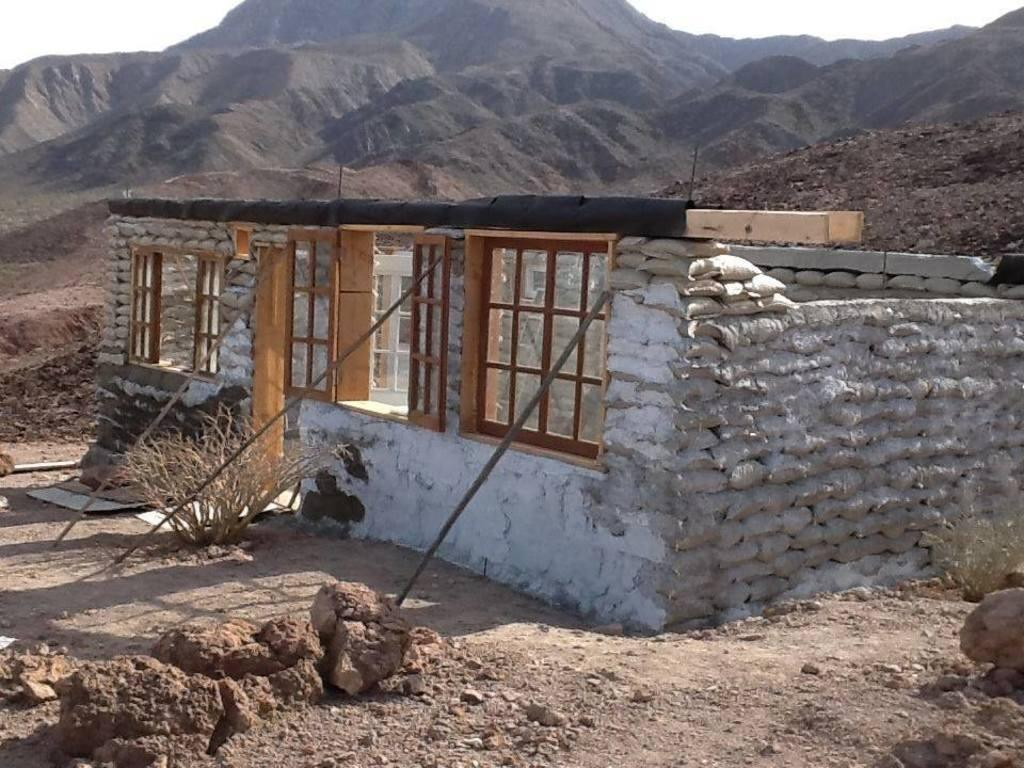What is at the bottom of the image? There is sand at the bottom of the image. What can be seen in the middle of the image? There are walls, windows, and trees in the middle of the image. What is the background of the image like? There are hills and sand visible in the background. What type of pie is being served in the lunchroom in the image? There is no lunchroom or pie present in the image. How many scales can be seen in the image? There are no scales visible in the image. 